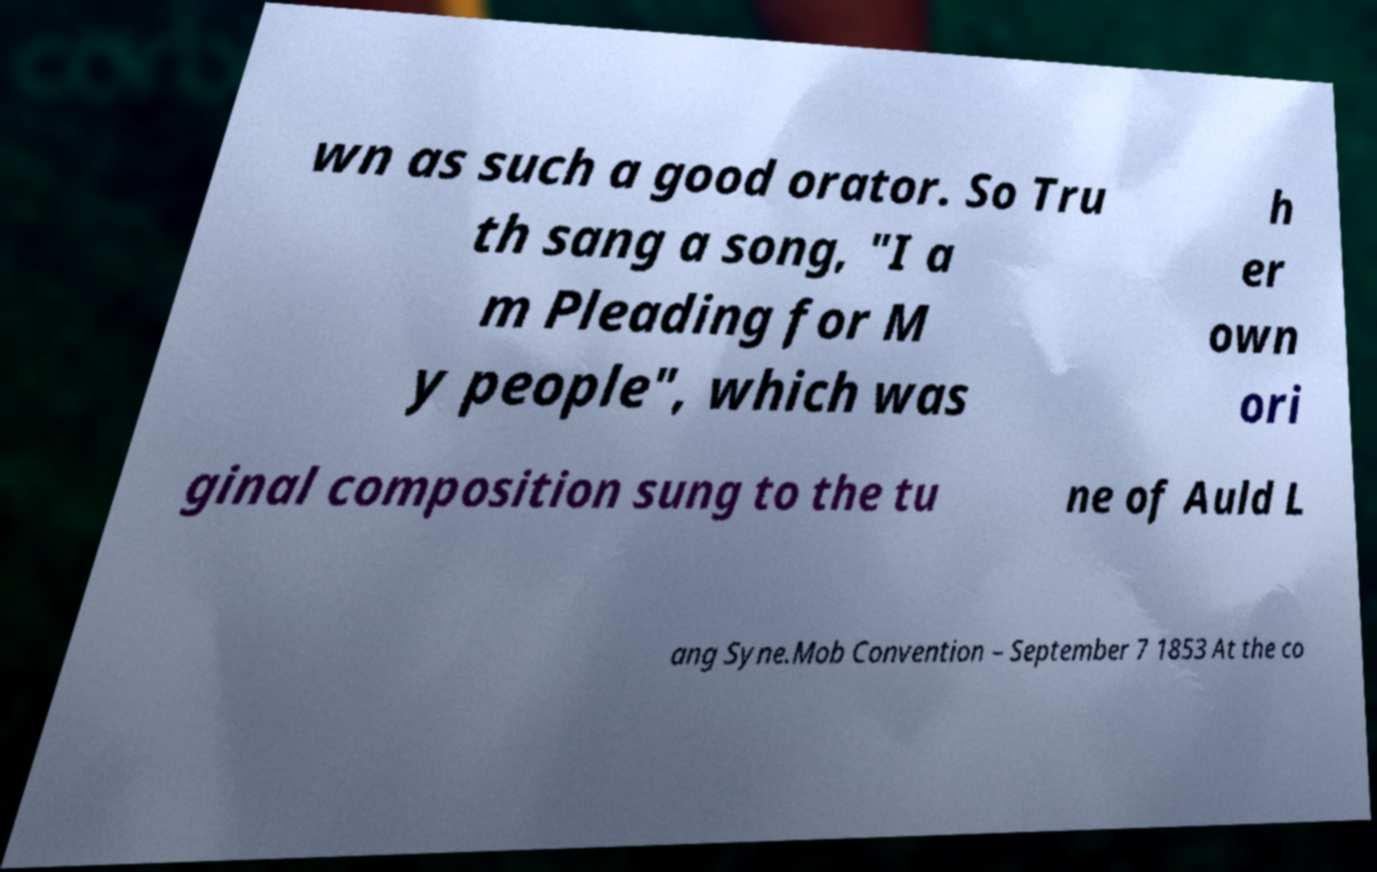Please identify and transcribe the text found in this image. wn as such a good orator. So Tru th sang a song, "I a m Pleading for M y people", which was h er own ori ginal composition sung to the tu ne of Auld L ang Syne.Mob Convention – September 7 1853 At the co 